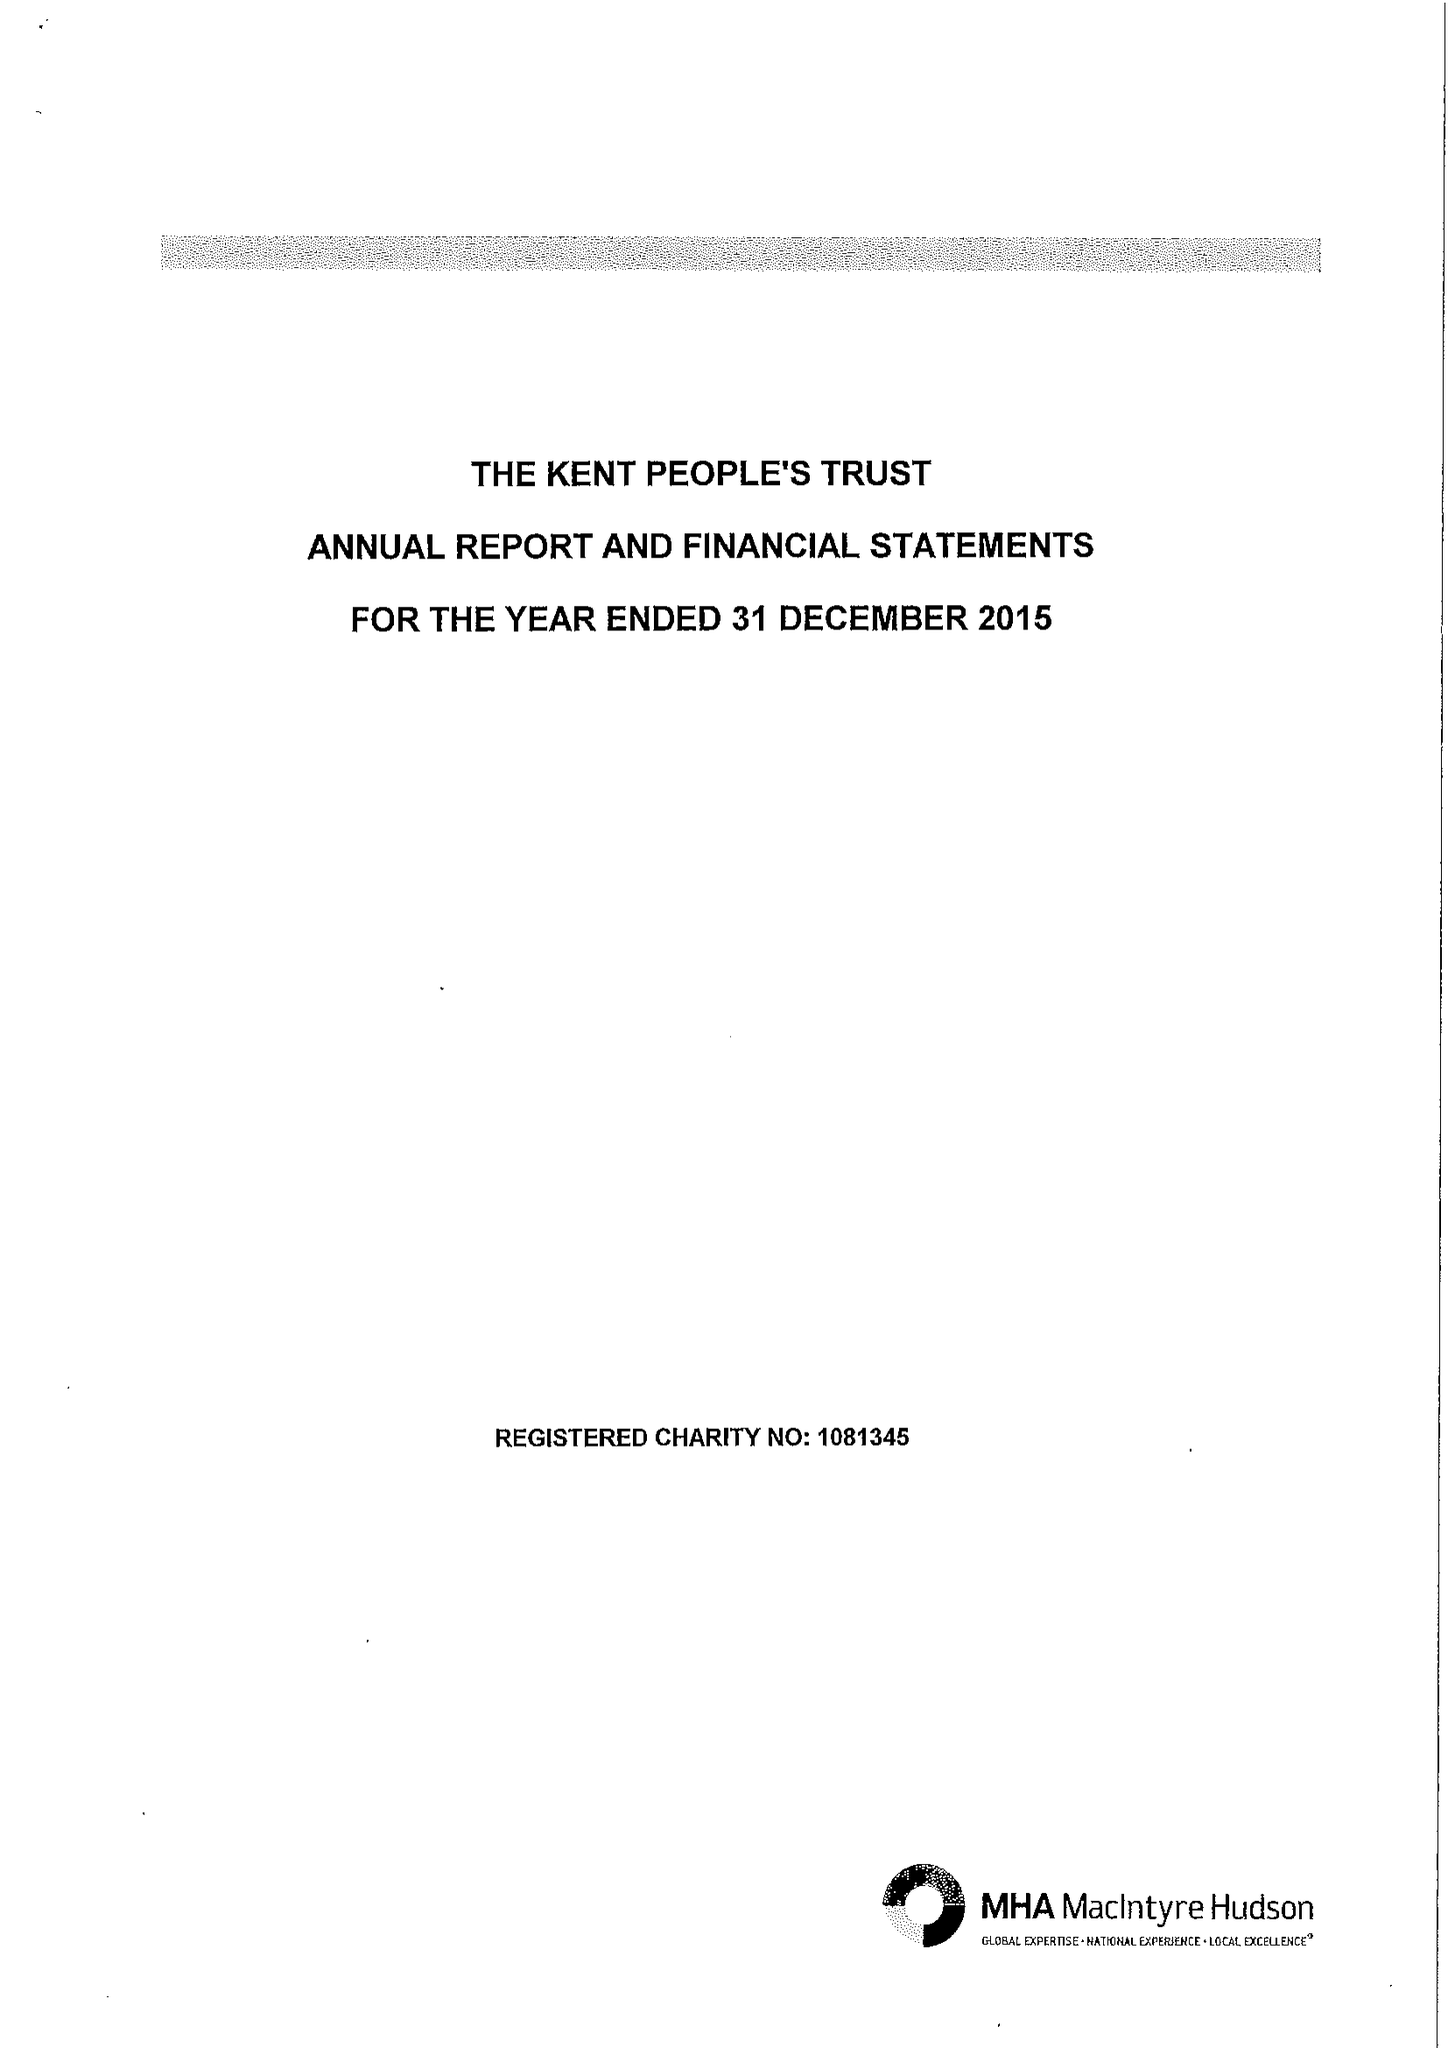What is the value for the address__postcode?
Answer the question using a single word or phrase. ME15 9BZ 